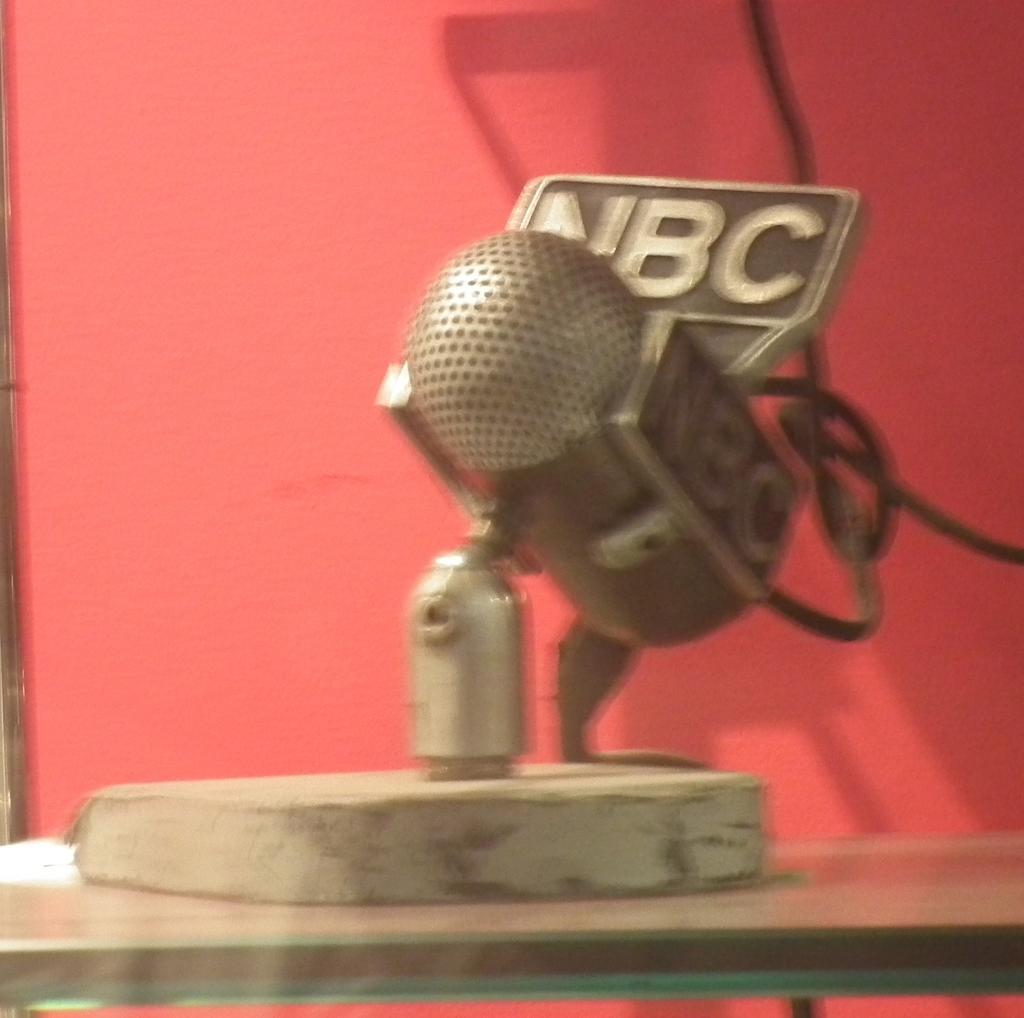In one or two sentences, can you explain what this image depicts? In this image there is a mic which is on the table in the center and on the top of the mic there is some text. In the background there is a curtain which is red in colour and there are wires. 